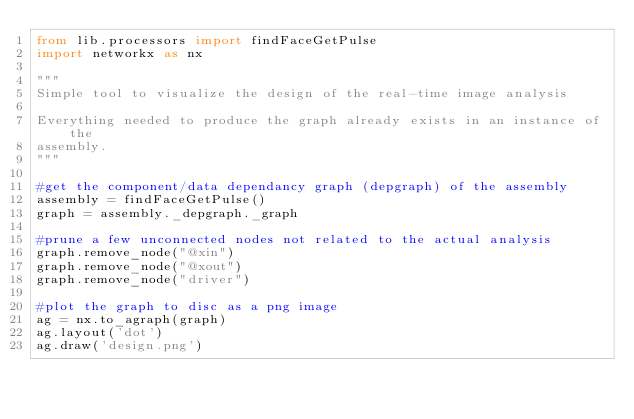<code> <loc_0><loc_0><loc_500><loc_500><_Python_>from lib.processors import findFaceGetPulse
import networkx as nx

"""
Simple tool to visualize the design of the real-time image analysis

Everything needed to produce the graph already exists in an instance of the
assembly.
"""

#get the component/data dependancy graph (depgraph) of the assembly
assembly = findFaceGetPulse()
graph = assembly._depgraph._graph

#prune a few unconnected nodes not related to the actual analysis
graph.remove_node("@xin")
graph.remove_node("@xout")
graph.remove_node("driver")

#plot the graph to disc as a png image
ag = nx.to_agraph(graph)
ag.layout('dot')
ag.draw('design.png')
</code> 